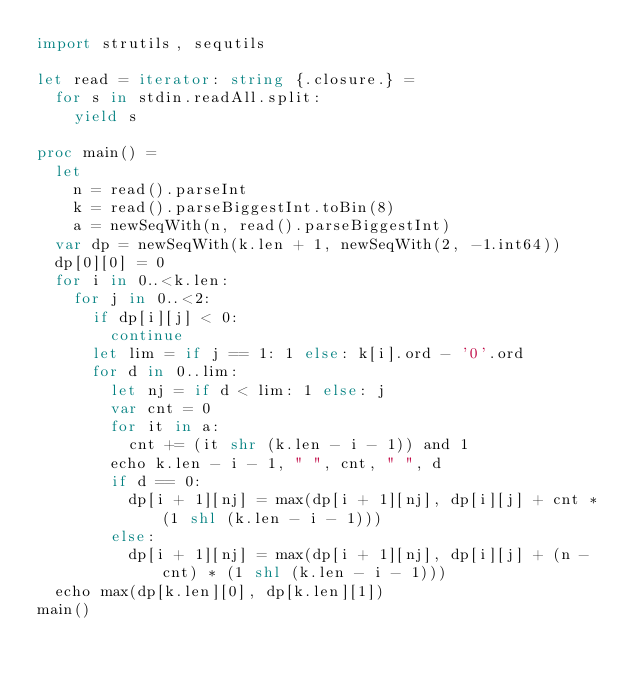Convert code to text. <code><loc_0><loc_0><loc_500><loc_500><_Nim_>import strutils, sequtils

let read = iterator: string {.closure.} =
  for s in stdin.readAll.split:
    yield s

proc main() =
  let
    n = read().parseInt
    k = read().parseBiggestInt.toBin(8)
    a = newSeqWith(n, read().parseBiggestInt)
  var dp = newSeqWith(k.len + 1, newSeqWith(2, -1.int64))
  dp[0][0] = 0
  for i in 0..<k.len:
    for j in 0..<2:
      if dp[i][j] < 0:
        continue
      let lim = if j == 1: 1 else: k[i].ord - '0'.ord
      for d in 0..lim:
        let nj = if d < lim: 1 else: j
        var cnt = 0
        for it in a:
          cnt += (it shr (k.len - i - 1)) and 1
        echo k.len - i - 1, " ", cnt, " ", d
        if d == 0:
          dp[i + 1][nj] = max(dp[i + 1][nj], dp[i][j] + cnt * (1 shl (k.len - i - 1)))
        else:
          dp[i + 1][nj] = max(dp[i + 1][nj], dp[i][j] + (n - cnt) * (1 shl (k.len - i - 1)))
  echo max(dp[k.len][0], dp[k.len][1])
main()
</code> 